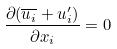Convert formula to latex. <formula><loc_0><loc_0><loc_500><loc_500>\frac { \partial ( \overline { u _ { i } } + u _ { i } ^ { \prime } ) } { \partial x _ { i } } = 0</formula> 